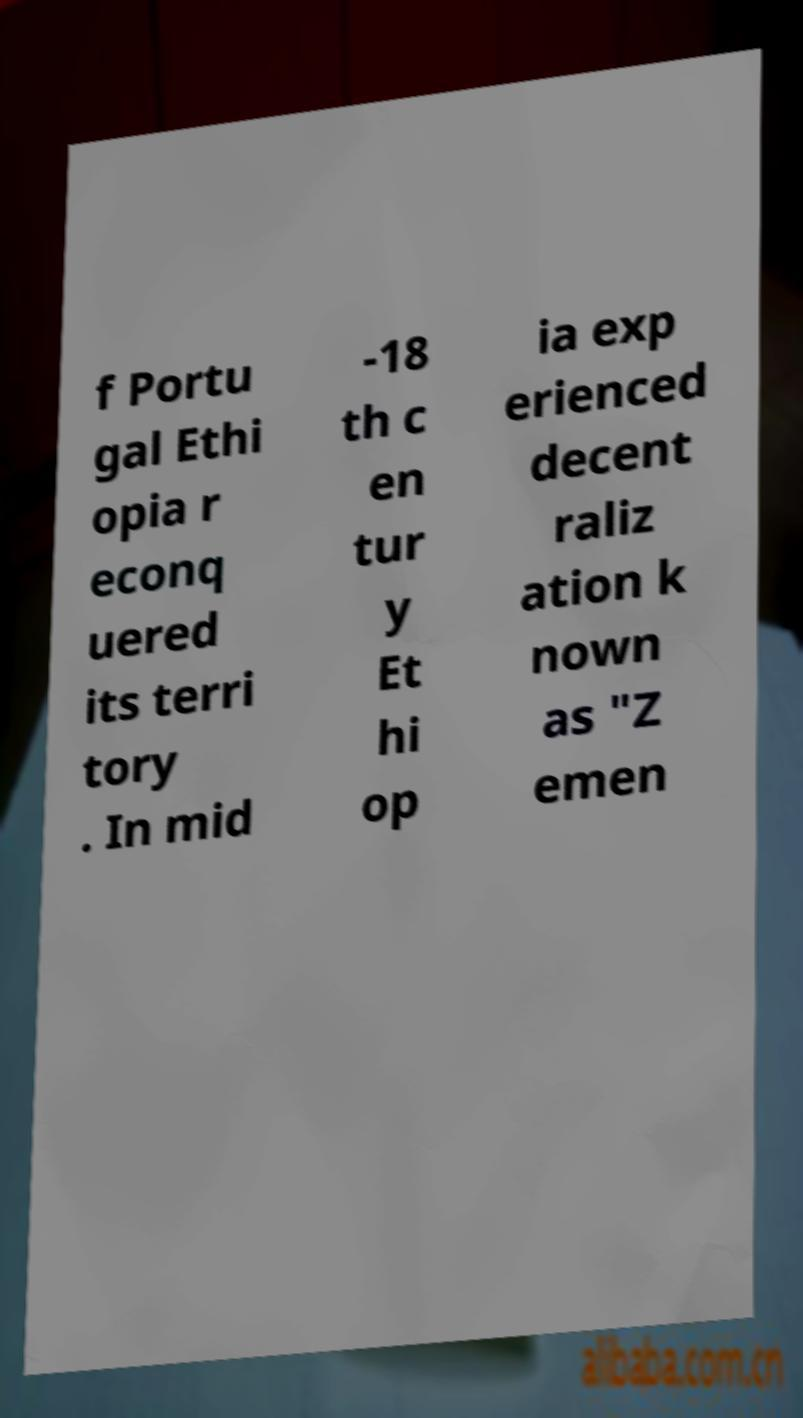Can you accurately transcribe the text from the provided image for me? f Portu gal Ethi opia r econq uered its terri tory . In mid -18 th c en tur y Et hi op ia exp erienced decent raliz ation k nown as "Z emen 